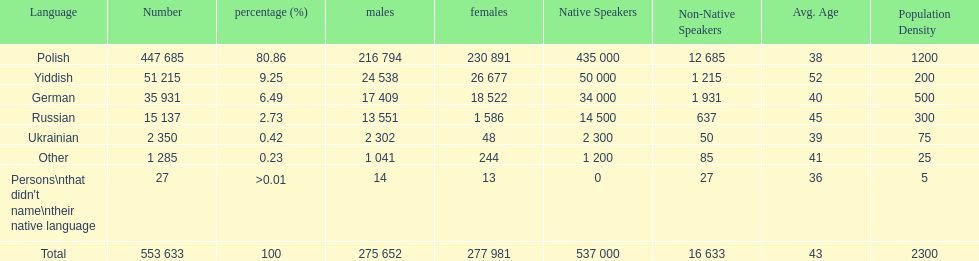How many male and female german speakers are there? 35931. 